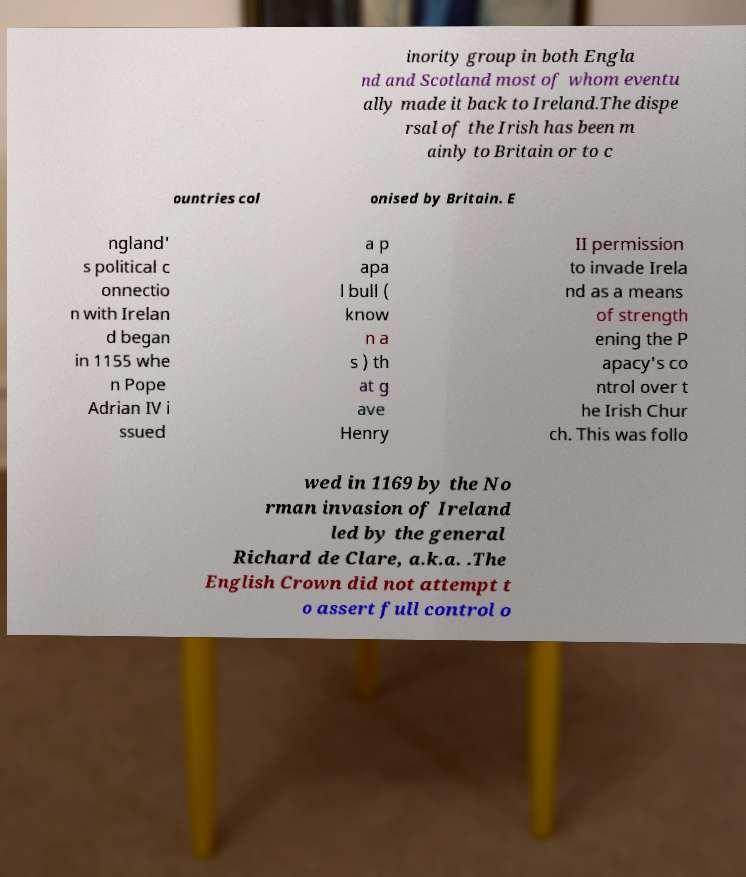Can you accurately transcribe the text from the provided image for me? inority group in both Engla nd and Scotland most of whom eventu ally made it back to Ireland.The dispe rsal of the Irish has been m ainly to Britain or to c ountries col onised by Britain. E ngland' s political c onnectio n with Irelan d began in 1155 whe n Pope Adrian IV i ssued a p apa l bull ( know n a s ) th at g ave Henry II permission to invade Irela nd as a means of strength ening the P apacy's co ntrol over t he Irish Chur ch. This was follo wed in 1169 by the No rman invasion of Ireland led by the general Richard de Clare, a.k.a. .The English Crown did not attempt t o assert full control o 